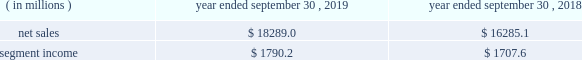Containerboard , kraft papers and saturating kraft .
Kapstone also owns victory packaging , a packaging solutions distribution company with facilities in the u.s. , canada and mexico .
We have included the financial results of kapstone in our corrugated packaging segment since the date of the acquisition .
On september 4 , 2018 , we completed the acquisition ( the 201cschl fcter acquisition 201d ) of schl fcter print pharma packaging ( 201cschl fcter 201d ) .
Schl fcter is a leading provider of differentiated paper and packaging solutions and a german-based supplier of a full range of leaflets and booklets .
The schl fcter acquisition allowed us to further enhance our pharmaceutical and automotive platform and expand our geographical footprint in europe to better serve our customers .
We have included the financial results of the acquired operations in our consumer packaging segment since the date of the acquisition .
On january 5 , 2018 , we completed the acquisition ( the 201cplymouth packaging acquisition 201d ) of substantially all of the assets of plymouth packaging , inc .
( 201cplymouth 201d ) .
The assets we acquired included plymouth 2019s 201cbox on demand 201d systems , which are manufactured by panotec , an italian manufacturer of packaging machines .
The addition of the box on demand systems enhanced our platform , differentiation and innovation .
These systems , which are located on customers 2019 sites under multi-year exclusive agreements , use fanfold corrugated to produce custom , on-demand corrugated packaging that is accurately sized for any product type according to the customer 2019s specifications .
Fanfold corrugated is continuous corrugated board , folded periodically to form an accordion-like stack of corrugated material .
As part of the transaction , westrock acquired plymouth 2019s equity interest in panotec and plymouth 2019s exclusive right from panotec to distribute panotec 2019s equipment in the u.s .
And canada .
We have fully integrated the approximately 60000 tons of containerboard used by plymouth annually .
We have included the financial results of plymouth in our corrugated packaging segment since the date of the acquisition .
See 201cnote 3 .
Acquisitions and investment 201d of the notes to consolidated financial statements for additional information .
See also item 1a .
201crisk factors 2014 we may be unsuccessful in making and integrating mergers , acquisitions and investments , and completing divestitures 201d .
Business .
In fiscal 2019 , we continued to pursue our strategy of offering differentiated paper and packaging solutions that help our customers win .
We successfully executed this strategy in fiscal 2019 in a rapidly changing cost and price environment .
Net sales of $ 18289.0 million for fiscal 2019 increased $ 2003.9 million , or 12.3% ( 12.3 % ) , compared to fiscal 2018 .
The increase was primarily due to the kapstone acquisition and higher selling price/mix in our corrugated packaging and consumer packaging segments .
These increases were partially offset by the absence of recycling net sales in fiscal 2019 as a result of conducting the operations primarily as a procurement function beginning in the first quarter of fiscal 2019 , lower volumes , unfavorable foreign currency impacts across our segments compared to the prior year and decreased land and development net sales .
Segment income increased $ 82.6 million in fiscal 2019 compared to fiscal 2018 , primarily due to increased corrugated packaging segment income that was partially offset by lower consumer packaging and land and development segment income .
The impact of the contribution from the acquired kapstone operations , higher selling price/mix across our segments and productivity improvements was largely offset by lower volumes across our segments , economic downtime , cost inflation , increased maintenance and scheduled strategic outage expense ( including projects at our mahrt , al and covington , va mills ) and lower land and development segment income due to the wind-down of sales .
With respect to segment income , we experienced higher levels of cost inflation in both our corrugated packaging and consumer packaging segments during fiscal 2019 as compared to fiscal 2018 that were partially offset by recovered fiber deflation .
The primary inflationary items were virgin fiber , freight , energy and wage and other costs .
We generated $ 2310.2 million of net cash provided by operating activities in fiscal 2019 , compared to $ 1931.2 million in fiscal 2018 .
We remained committed to our disciplined capital allocation strategy during fiscal .
What percent did net sales increase between 2018 and 2019? 
Computations: (18289.0 - 16285.1)
Answer: 2003.9. 